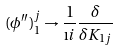Convert formula to latex. <formula><loc_0><loc_0><loc_500><loc_500>( \phi ^ { \prime \prime } ) _ { 1 } ^ { j } \rightarrow \frac { 1 } { \i i } \frac { \delta } { \delta K _ { 1 j } }</formula> 